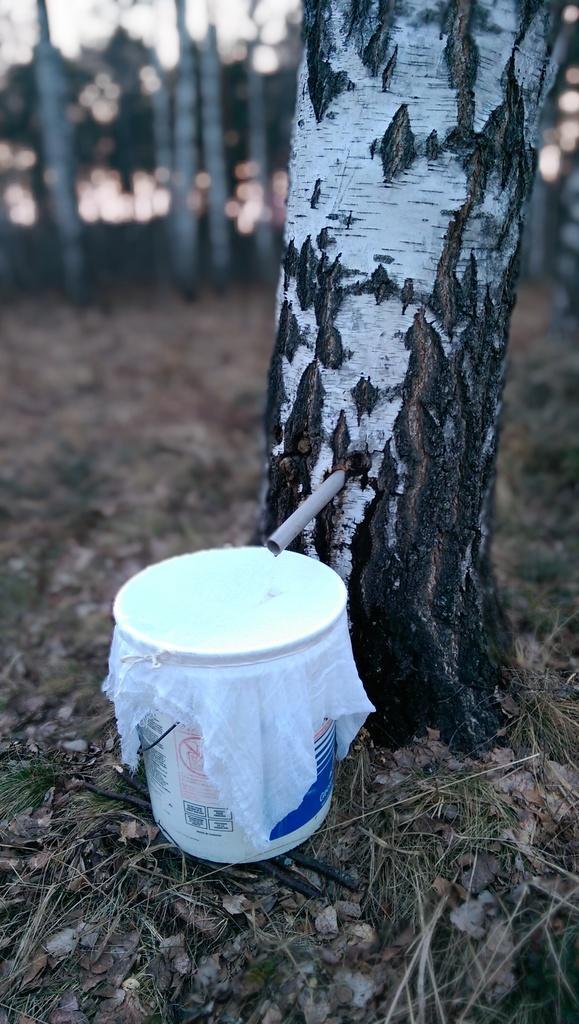Please provide a concise description of this image. In this image there is a tree trunk in the middle. Beside the tree there is a bucket which is covered with the cloth. There is a pipe which is fixed to the tree. In the background there are trees. On the ground there are dry sticks and dry leaves. 